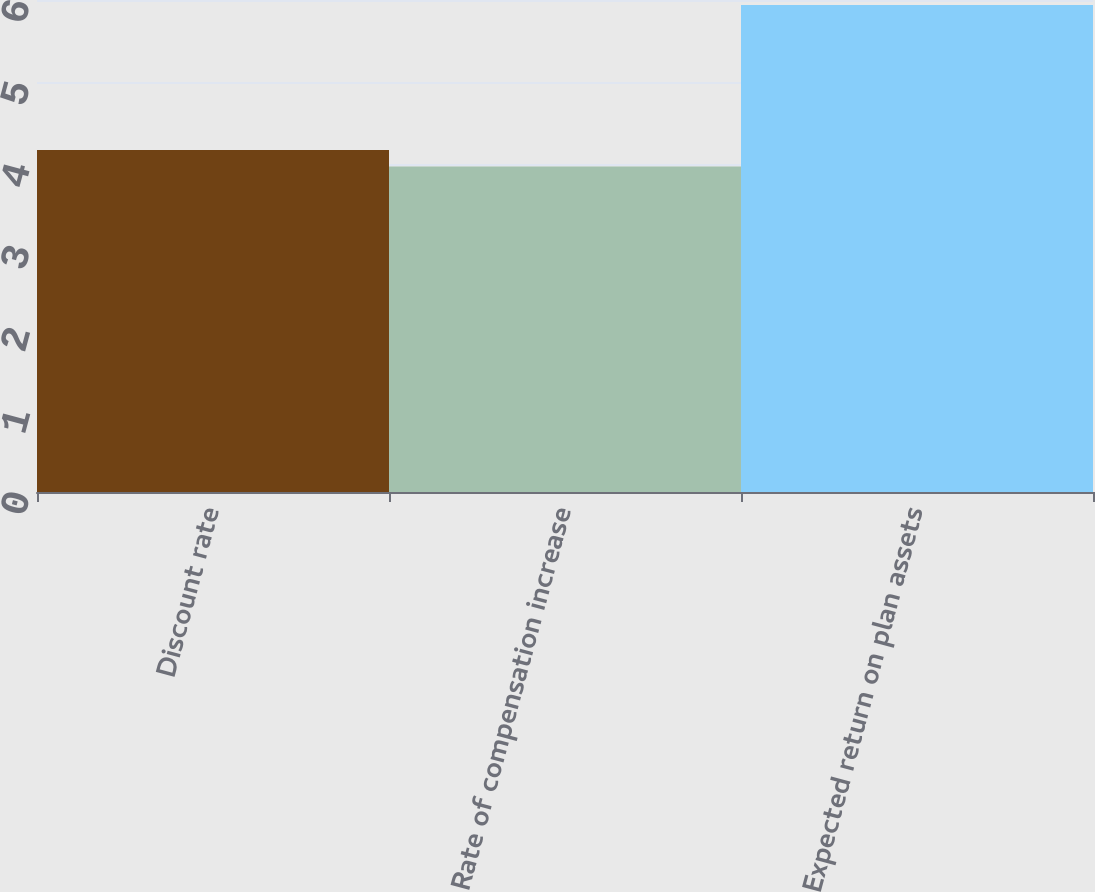<chart> <loc_0><loc_0><loc_500><loc_500><bar_chart><fcel>Discount rate<fcel>Rate of compensation increase<fcel>Expected return on plan assets<nl><fcel>4.17<fcel>3.97<fcel>5.94<nl></chart> 